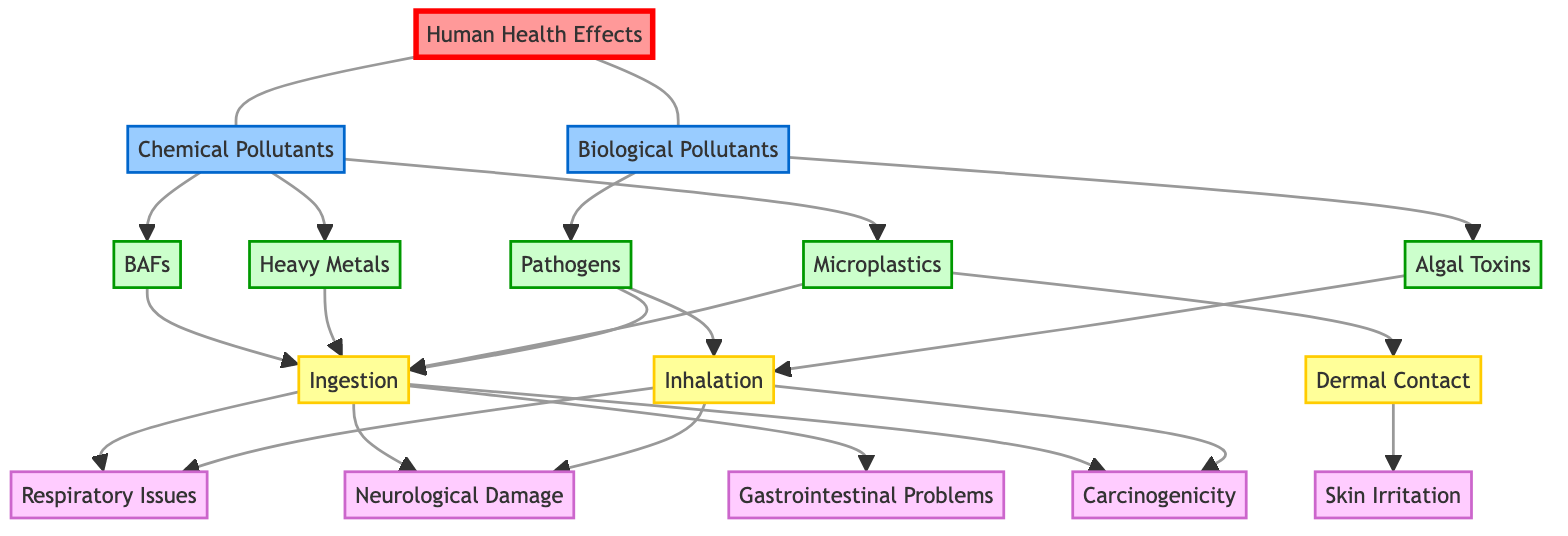What are the types of pollutants illustrated in the diagram? The diagram shows two categories of pollutants: Chemical Pollutants and Biological Pollutants. These are the main sources that contribute to potential human health effects from contaminants found in coastal waters.
Answer: Chemical Pollutants, Biological Pollutants How many types of Chemical Pollutants are present? The diagram lists three types under Chemical Pollutants: BAFs, Heavy Metals, and Microplastics. By counting these types, we confirm the total.
Answer: 3 What is a type of Biological Pollutant mentioned? Among the Biological Pollutants displayed in the diagram, Pathogens is one specific type that poses a risk to human health along with Algal Toxins.
Answer: Pathogens How do Heavy Metals expose humans to risks? The diagram indicates that Heavy Metals primarily contribute to human exposure through Ingestion. This connection reveals how these pollutants can enter the human body and lead to health issues.
Answer: Ingestion How can humans come into contact with Microplastics according to this diagram? The diagram shows that Microplastics can lead to human exposure through Ingestion as they may contaminate food and drinks. Additionally, they can also expose humans via Dermal Contact when interacting with contaminated water.
Answer: Ingestion, Dermal Contact What health effect is connected to Dermal Contact? The diagram illustrates that Dermal Contact is linked specifically to Skin Irritation as a health effect, demonstrating the type of health damage associated with such exposure.
Answer: Skin Irritation Which health effects are caused by Inhalation exposure? The effects associated with Inhalation shown in the diagram include Respiratory Issues, Neurological Damage, and Carcinogenicity. This indicates multiple serious health concerns from inhaling contaminated air.
Answer: Respiratory Issues, Neurological Damage, Carcinogenicity How are Algal Toxins associated with exposure? Algal Toxins in the diagram are indicated to cause exposure through Ingestion and Inhalation, highlighting the pathways through which humans can risk their health due to these toxins.
Answer: Ingestion, Inhalation What is the total number of health effects depicted in the diagram? The diagram shows six specific health effects connected to the types of pollutants. A quick count reveals these as Respiratory Issues, Neurological Damage, Gastrointestinal Problems, Skin Irritation, and Carcinogenicity.
Answer: 6 